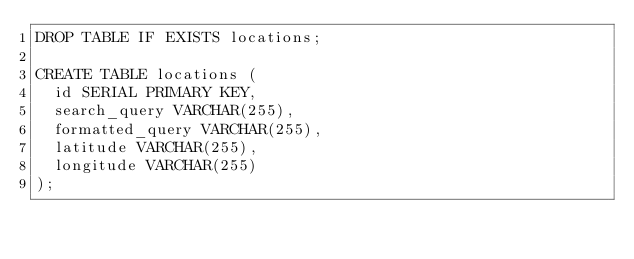Convert code to text. <code><loc_0><loc_0><loc_500><loc_500><_SQL_>DROP TABLE IF EXISTS locations;

CREATE TABLE locations (
  id SERIAL PRIMARY KEY,
  search_query VARCHAR(255),
  formatted_query VARCHAR(255),
  latitude VARCHAR(255),
  longitude VARCHAR(255)
);
</code> 